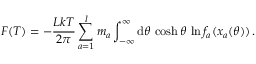<formula> <loc_0><loc_0><loc_500><loc_500>F ( T ) = - \frac { L k T } { 2 \pi } \sum _ { a = 1 } ^ { l } m _ { a } \int _ { - \infty } ^ { \infty } d \theta \, \cosh \theta \, \ln f _ { a } ( x _ { a } ( \theta ) ) \, .</formula> 